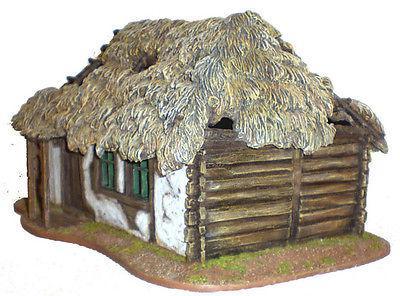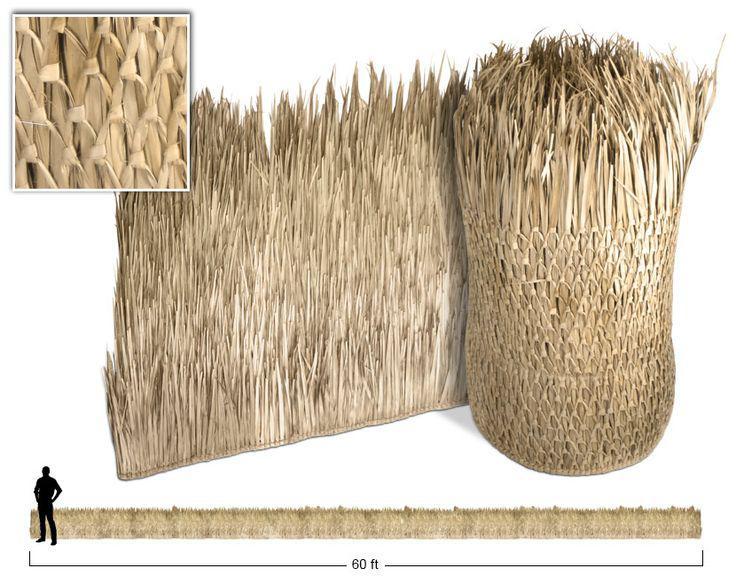The first image is the image on the left, the second image is the image on the right. Analyze the images presented: Is the assertion "The left image is just of a sample of hatch, no parts of a house can be seen." valid? Answer yes or no. No. The first image is the image on the left, the second image is the image on the right. Considering the images on both sides, is "An image shows real thatch applied to a flat sloped roof, with something resembling ladder rungs on the right side." valid? Answer yes or no. No. 